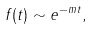Convert formula to latex. <formula><loc_0><loc_0><loc_500><loc_500>f ( t ) \sim e ^ { - m t } ,</formula> 